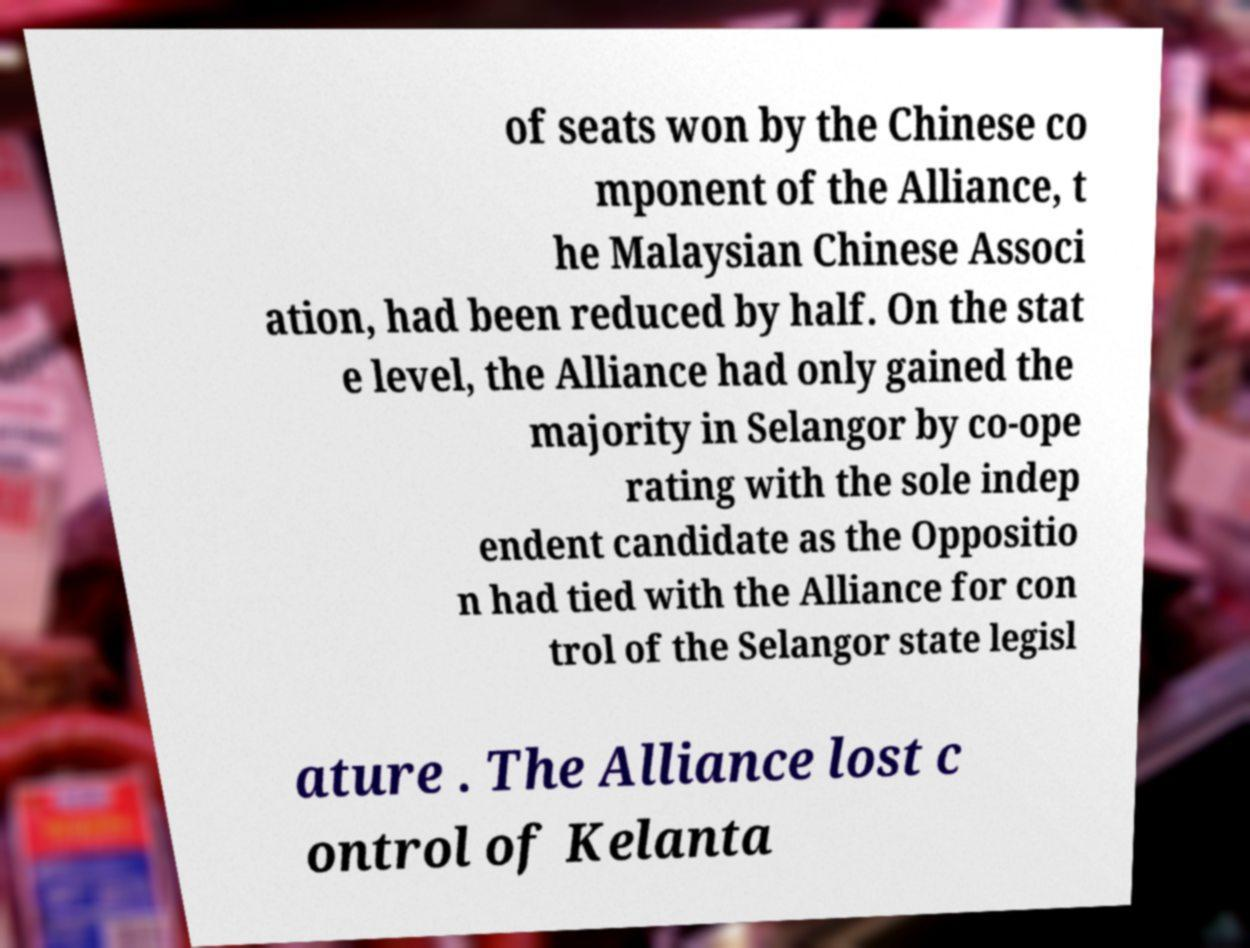Please read and relay the text visible in this image. What does it say? of seats won by the Chinese co mponent of the Alliance, t he Malaysian Chinese Associ ation, had been reduced by half. On the stat e level, the Alliance had only gained the majority in Selangor by co-ope rating with the sole indep endent candidate as the Oppositio n had tied with the Alliance for con trol of the Selangor state legisl ature . The Alliance lost c ontrol of Kelanta 